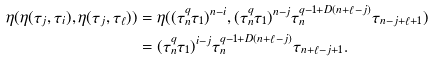<formula> <loc_0><loc_0><loc_500><loc_500>\eta ( \eta ( \tau _ { j } , \tau _ { i } ) , \eta ( \tau _ { j } , \tau _ { \ell } ) ) & = \eta ( ( \tau _ { n } ^ { q } \tau _ { 1 } ) ^ { n - i } , ( \tau _ { n } ^ { q } \tau _ { 1 } ) ^ { n - j } \tau _ { n } ^ { q - 1 + D ( n + \ell - j ) } \tau _ { n - j + \ell + 1 } ) \\ & = ( \tau _ { n } ^ { q } \tau _ { 1 } ) ^ { i - j } \tau _ { n } ^ { q - 1 + D ( n + \ell - j ) } \tau _ { n + \ell - j + 1 } .</formula> 